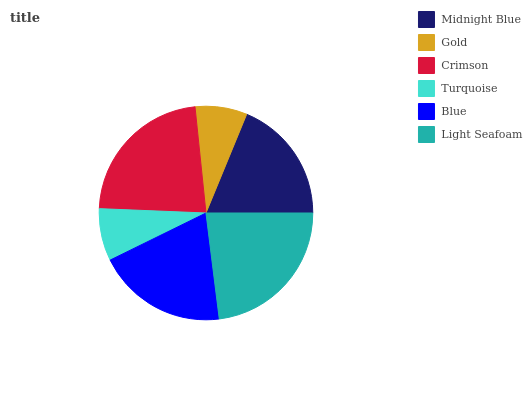Is Gold the minimum?
Answer yes or no. Yes. Is Light Seafoam the maximum?
Answer yes or no. Yes. Is Crimson the minimum?
Answer yes or no. No. Is Crimson the maximum?
Answer yes or no. No. Is Crimson greater than Gold?
Answer yes or no. Yes. Is Gold less than Crimson?
Answer yes or no. Yes. Is Gold greater than Crimson?
Answer yes or no. No. Is Crimson less than Gold?
Answer yes or no. No. Is Blue the high median?
Answer yes or no. Yes. Is Midnight Blue the low median?
Answer yes or no. Yes. Is Turquoise the high median?
Answer yes or no. No. Is Blue the low median?
Answer yes or no. No. 